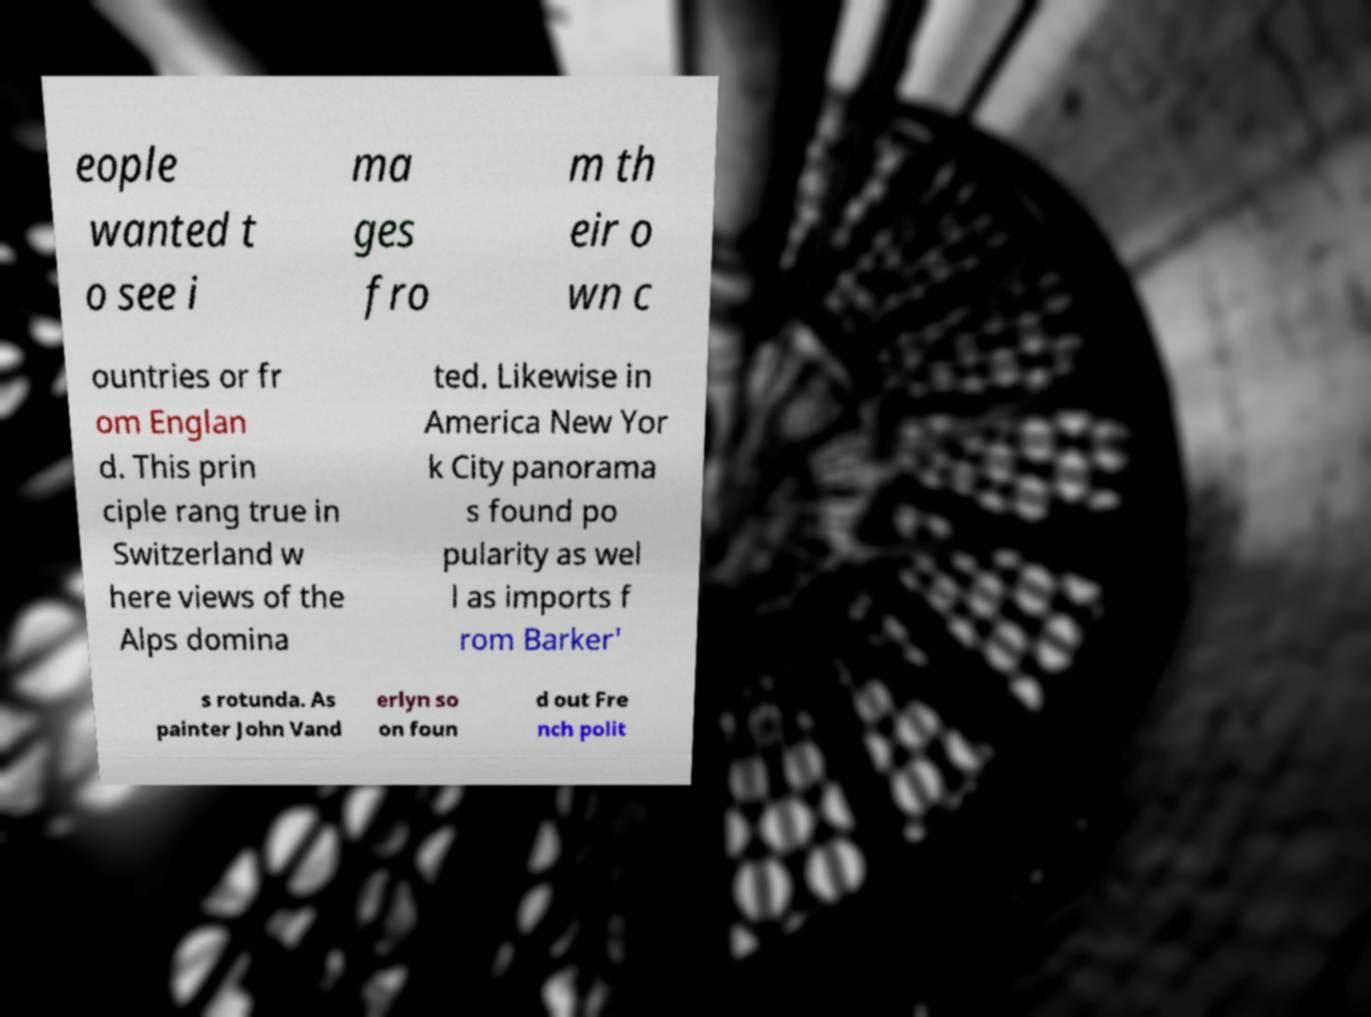Please identify and transcribe the text found in this image. eople wanted t o see i ma ges fro m th eir o wn c ountries or fr om Englan d. This prin ciple rang true in Switzerland w here views of the Alps domina ted. Likewise in America New Yor k City panorama s found po pularity as wel l as imports f rom Barker' s rotunda. As painter John Vand erlyn so on foun d out Fre nch polit 